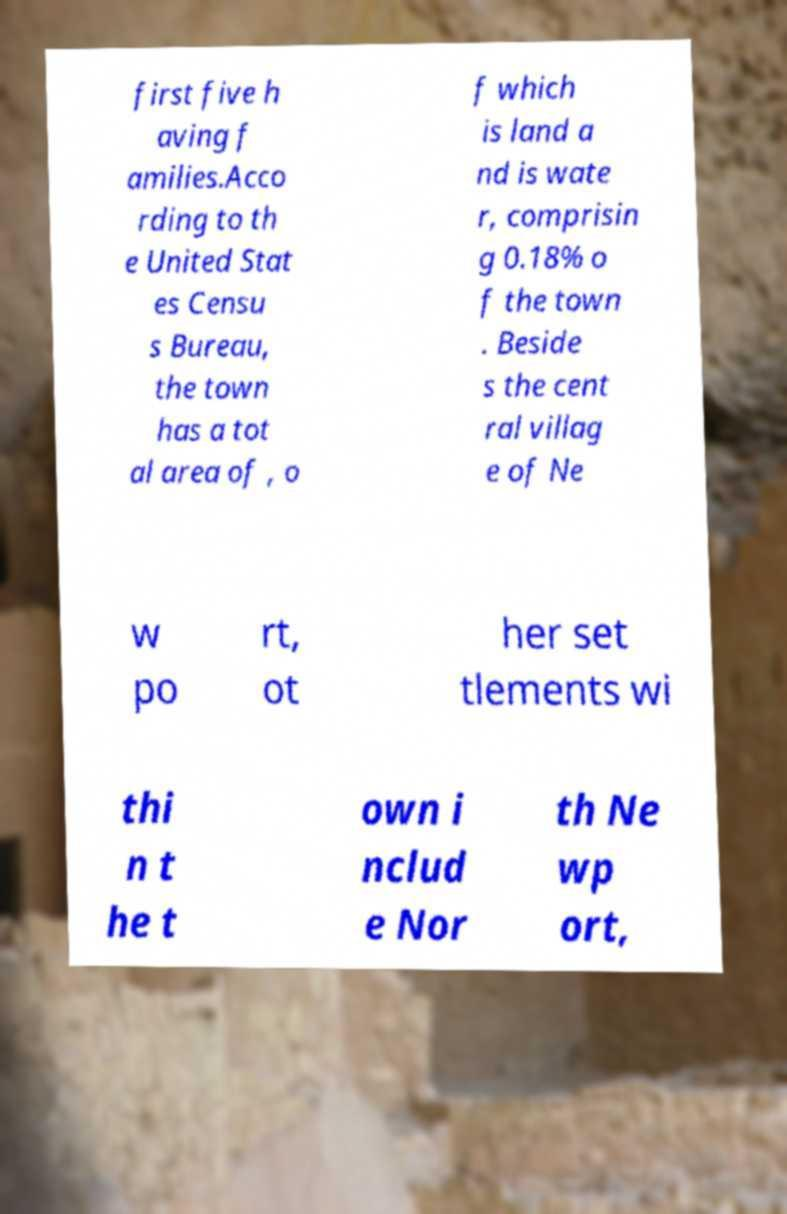Can you accurately transcribe the text from the provided image for me? first five h aving f amilies.Acco rding to th e United Stat es Censu s Bureau, the town has a tot al area of , o f which is land a nd is wate r, comprisin g 0.18% o f the town . Beside s the cent ral villag e of Ne w po rt, ot her set tlements wi thi n t he t own i nclud e Nor th Ne wp ort, 